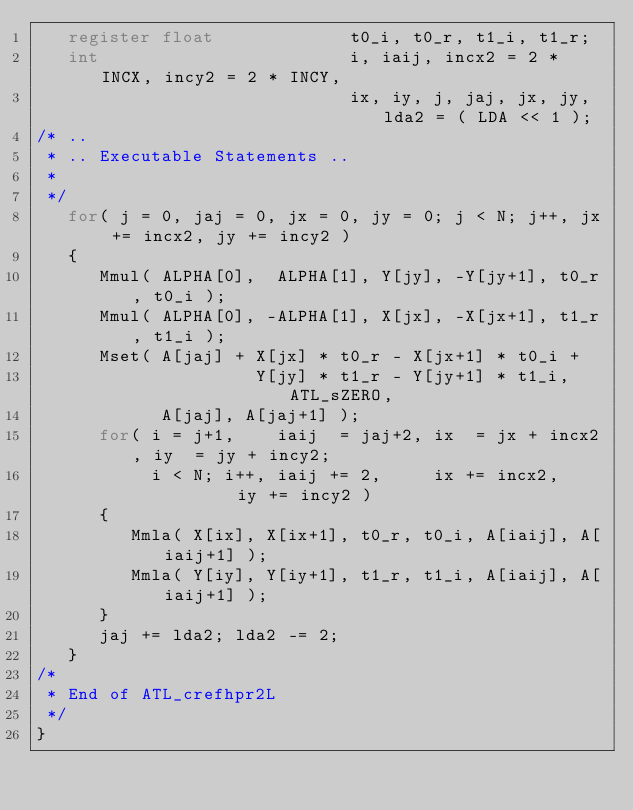<code> <loc_0><loc_0><loc_500><loc_500><_C_>   register float             t0_i, t0_r, t1_i, t1_r;
   int                        i, iaij, incx2 = 2 * INCX, incy2 = 2 * INCY,
                              ix, iy, j, jaj, jx, jy, lda2 = ( LDA << 1 );
/* ..
 * .. Executable Statements ..
 *
 */
   for( j = 0, jaj = 0, jx = 0, jy = 0; j < N; j++, jx += incx2, jy += incy2 )
   {
      Mmul( ALPHA[0],  ALPHA[1], Y[jy], -Y[jy+1], t0_r, t0_i );
      Mmul( ALPHA[0], -ALPHA[1], X[jx], -X[jx+1], t1_r, t1_i );
      Mset( A[jaj] + X[jx] * t0_r - X[jx+1] * t0_i +
                     Y[jy] * t1_r - Y[jy+1] * t1_i, ATL_sZERO,
            A[jaj], A[jaj+1] );
      for( i = j+1,    iaij  = jaj+2, ix  = jx + incx2, iy  = jy + incy2;
           i < N; i++, iaij += 2,     ix += incx2,      iy += incy2 )
      {
         Mmla( X[ix], X[ix+1], t0_r, t0_i, A[iaij], A[iaij+1] );
         Mmla( Y[iy], Y[iy+1], t1_r, t1_i, A[iaij], A[iaij+1] );
      }
      jaj += lda2; lda2 -= 2;
   }
/*
 * End of ATL_crefhpr2L
 */
}
</code> 